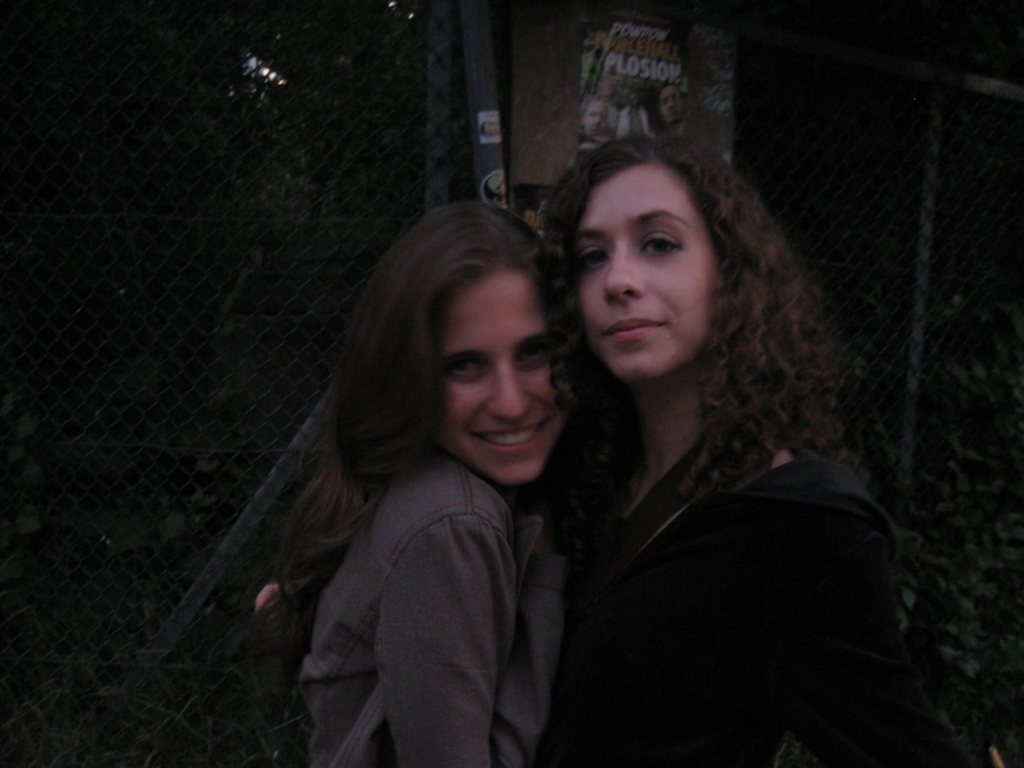What is the overall brightness of the image?
A. High
B. Bright
C. Low The overall brightness of the image is low, as indicated by the muted lighting and the prevalence of shadows. The subdued luminance contributes to the intimate atmosphere and emphasizes the subjects at the center. 